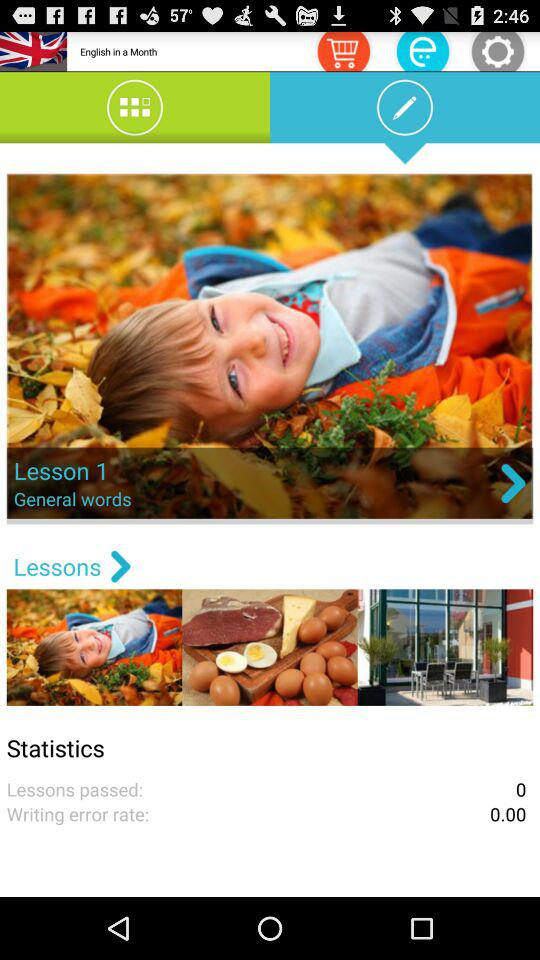What is the writing error rate? The writing error rate is 0.00. 